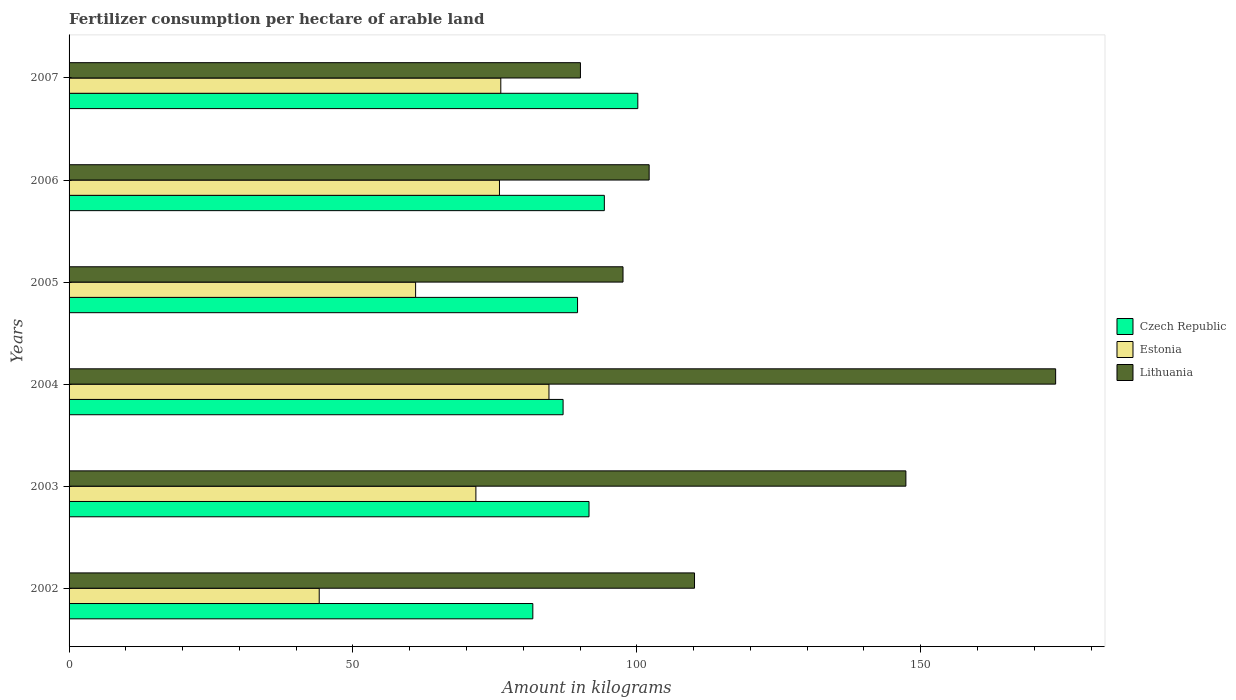How many different coloured bars are there?
Keep it short and to the point. 3. How many groups of bars are there?
Your answer should be very brief. 6. Are the number of bars per tick equal to the number of legend labels?
Your response must be concise. Yes. Are the number of bars on each tick of the Y-axis equal?
Provide a succinct answer. Yes. How many bars are there on the 4th tick from the top?
Provide a succinct answer. 3. How many bars are there on the 2nd tick from the bottom?
Offer a very short reply. 3. What is the label of the 6th group of bars from the top?
Your response must be concise. 2002. What is the amount of fertilizer consumption in Lithuania in 2002?
Provide a succinct answer. 110.15. Across all years, what is the maximum amount of fertilizer consumption in Czech Republic?
Offer a very short reply. 100.17. Across all years, what is the minimum amount of fertilizer consumption in Czech Republic?
Keep it short and to the point. 81.68. What is the total amount of fertilizer consumption in Estonia in the graph?
Keep it short and to the point. 413.1. What is the difference between the amount of fertilizer consumption in Estonia in 2002 and that in 2004?
Make the answer very short. -40.46. What is the difference between the amount of fertilizer consumption in Lithuania in 2004 and the amount of fertilizer consumption in Czech Republic in 2003?
Your answer should be very brief. 82.19. What is the average amount of fertilizer consumption in Estonia per year?
Your answer should be compact. 68.85. In the year 2002, what is the difference between the amount of fertilizer consumption in Czech Republic and amount of fertilizer consumption in Estonia?
Ensure brevity in your answer.  37.62. What is the ratio of the amount of fertilizer consumption in Estonia in 2003 to that in 2005?
Provide a short and direct response. 1.17. Is the amount of fertilizer consumption in Estonia in 2006 less than that in 2007?
Your answer should be very brief. Yes. What is the difference between the highest and the second highest amount of fertilizer consumption in Czech Republic?
Your response must be concise. 5.9. What is the difference between the highest and the lowest amount of fertilizer consumption in Estonia?
Give a very brief answer. 40.46. Is the sum of the amount of fertilizer consumption in Czech Republic in 2005 and 2006 greater than the maximum amount of fertilizer consumption in Lithuania across all years?
Keep it short and to the point. Yes. What does the 2nd bar from the top in 2004 represents?
Your answer should be very brief. Estonia. What does the 1st bar from the bottom in 2004 represents?
Provide a succinct answer. Czech Republic. Is it the case that in every year, the sum of the amount of fertilizer consumption in Czech Republic and amount of fertilizer consumption in Lithuania is greater than the amount of fertilizer consumption in Estonia?
Your answer should be compact. Yes. How many years are there in the graph?
Make the answer very short. 6. What is the difference between two consecutive major ticks on the X-axis?
Make the answer very short. 50. Does the graph contain any zero values?
Your answer should be very brief. No. Where does the legend appear in the graph?
Provide a succinct answer. Center right. How many legend labels are there?
Your answer should be very brief. 3. How are the legend labels stacked?
Give a very brief answer. Vertical. What is the title of the graph?
Give a very brief answer. Fertilizer consumption per hectare of arable land. What is the label or title of the X-axis?
Make the answer very short. Amount in kilograms. What is the label or title of the Y-axis?
Your answer should be very brief. Years. What is the Amount in kilograms of Czech Republic in 2002?
Offer a terse response. 81.68. What is the Amount in kilograms of Estonia in 2002?
Provide a succinct answer. 44.06. What is the Amount in kilograms of Lithuania in 2002?
Provide a short and direct response. 110.15. What is the Amount in kilograms in Czech Republic in 2003?
Ensure brevity in your answer.  91.57. What is the Amount in kilograms in Estonia in 2003?
Give a very brief answer. 71.65. What is the Amount in kilograms in Lithuania in 2003?
Ensure brevity in your answer.  147.38. What is the Amount in kilograms of Czech Republic in 2004?
Offer a terse response. 87.01. What is the Amount in kilograms of Estonia in 2004?
Your answer should be very brief. 84.52. What is the Amount in kilograms of Lithuania in 2004?
Make the answer very short. 173.76. What is the Amount in kilograms in Czech Republic in 2005?
Give a very brief answer. 89.56. What is the Amount in kilograms of Estonia in 2005?
Your answer should be compact. 61.03. What is the Amount in kilograms in Lithuania in 2005?
Keep it short and to the point. 97.56. What is the Amount in kilograms of Czech Republic in 2006?
Your answer should be very brief. 94.27. What is the Amount in kilograms of Estonia in 2006?
Your response must be concise. 75.8. What is the Amount in kilograms of Lithuania in 2006?
Provide a succinct answer. 102.17. What is the Amount in kilograms of Czech Republic in 2007?
Your answer should be compact. 100.17. What is the Amount in kilograms of Estonia in 2007?
Ensure brevity in your answer.  76.04. What is the Amount in kilograms in Lithuania in 2007?
Your answer should be very brief. 90.07. Across all years, what is the maximum Amount in kilograms of Czech Republic?
Offer a very short reply. 100.17. Across all years, what is the maximum Amount in kilograms of Estonia?
Give a very brief answer. 84.52. Across all years, what is the maximum Amount in kilograms in Lithuania?
Keep it short and to the point. 173.76. Across all years, what is the minimum Amount in kilograms of Czech Republic?
Offer a terse response. 81.68. Across all years, what is the minimum Amount in kilograms in Estonia?
Keep it short and to the point. 44.06. Across all years, what is the minimum Amount in kilograms of Lithuania?
Your answer should be very brief. 90.07. What is the total Amount in kilograms of Czech Republic in the graph?
Provide a succinct answer. 544.26. What is the total Amount in kilograms of Estonia in the graph?
Offer a very short reply. 413.1. What is the total Amount in kilograms of Lithuania in the graph?
Your answer should be compact. 721.1. What is the difference between the Amount in kilograms in Czech Republic in 2002 and that in 2003?
Offer a very short reply. -9.9. What is the difference between the Amount in kilograms in Estonia in 2002 and that in 2003?
Offer a terse response. -27.59. What is the difference between the Amount in kilograms in Lithuania in 2002 and that in 2003?
Your answer should be compact. -37.23. What is the difference between the Amount in kilograms of Czech Republic in 2002 and that in 2004?
Your response must be concise. -5.33. What is the difference between the Amount in kilograms in Estonia in 2002 and that in 2004?
Ensure brevity in your answer.  -40.46. What is the difference between the Amount in kilograms in Lithuania in 2002 and that in 2004?
Keep it short and to the point. -63.61. What is the difference between the Amount in kilograms in Czech Republic in 2002 and that in 2005?
Your answer should be very brief. -7.88. What is the difference between the Amount in kilograms of Estonia in 2002 and that in 2005?
Your answer should be very brief. -16.98. What is the difference between the Amount in kilograms of Lithuania in 2002 and that in 2005?
Your answer should be compact. 12.59. What is the difference between the Amount in kilograms of Czech Republic in 2002 and that in 2006?
Provide a succinct answer. -12.59. What is the difference between the Amount in kilograms in Estonia in 2002 and that in 2006?
Provide a succinct answer. -31.75. What is the difference between the Amount in kilograms of Lithuania in 2002 and that in 2006?
Your answer should be compact. 7.99. What is the difference between the Amount in kilograms of Czech Republic in 2002 and that in 2007?
Keep it short and to the point. -18.49. What is the difference between the Amount in kilograms in Estonia in 2002 and that in 2007?
Offer a terse response. -31.98. What is the difference between the Amount in kilograms of Lithuania in 2002 and that in 2007?
Keep it short and to the point. 20.09. What is the difference between the Amount in kilograms of Czech Republic in 2003 and that in 2004?
Your response must be concise. 4.57. What is the difference between the Amount in kilograms of Estonia in 2003 and that in 2004?
Offer a terse response. -12.87. What is the difference between the Amount in kilograms of Lithuania in 2003 and that in 2004?
Provide a succinct answer. -26.38. What is the difference between the Amount in kilograms of Czech Republic in 2003 and that in 2005?
Provide a short and direct response. 2.02. What is the difference between the Amount in kilograms in Estonia in 2003 and that in 2005?
Make the answer very short. 10.62. What is the difference between the Amount in kilograms of Lithuania in 2003 and that in 2005?
Provide a short and direct response. 49.82. What is the difference between the Amount in kilograms of Czech Republic in 2003 and that in 2006?
Your answer should be very brief. -2.7. What is the difference between the Amount in kilograms in Estonia in 2003 and that in 2006?
Provide a short and direct response. -4.15. What is the difference between the Amount in kilograms in Lithuania in 2003 and that in 2006?
Your answer should be very brief. 45.22. What is the difference between the Amount in kilograms of Czech Republic in 2003 and that in 2007?
Offer a terse response. -8.6. What is the difference between the Amount in kilograms of Estonia in 2003 and that in 2007?
Ensure brevity in your answer.  -4.39. What is the difference between the Amount in kilograms of Lithuania in 2003 and that in 2007?
Provide a short and direct response. 57.32. What is the difference between the Amount in kilograms in Czech Republic in 2004 and that in 2005?
Offer a very short reply. -2.55. What is the difference between the Amount in kilograms of Estonia in 2004 and that in 2005?
Your response must be concise. 23.49. What is the difference between the Amount in kilograms of Lithuania in 2004 and that in 2005?
Provide a succinct answer. 76.2. What is the difference between the Amount in kilograms of Czech Republic in 2004 and that in 2006?
Make the answer very short. -7.27. What is the difference between the Amount in kilograms of Estonia in 2004 and that in 2006?
Your response must be concise. 8.72. What is the difference between the Amount in kilograms in Lithuania in 2004 and that in 2006?
Your answer should be compact. 71.59. What is the difference between the Amount in kilograms in Czech Republic in 2004 and that in 2007?
Offer a very short reply. -13.16. What is the difference between the Amount in kilograms of Estonia in 2004 and that in 2007?
Give a very brief answer. 8.48. What is the difference between the Amount in kilograms of Lithuania in 2004 and that in 2007?
Offer a very short reply. 83.69. What is the difference between the Amount in kilograms in Czech Republic in 2005 and that in 2006?
Your answer should be very brief. -4.72. What is the difference between the Amount in kilograms of Estonia in 2005 and that in 2006?
Keep it short and to the point. -14.77. What is the difference between the Amount in kilograms of Lithuania in 2005 and that in 2006?
Your response must be concise. -4.6. What is the difference between the Amount in kilograms in Czech Republic in 2005 and that in 2007?
Provide a succinct answer. -10.61. What is the difference between the Amount in kilograms of Estonia in 2005 and that in 2007?
Give a very brief answer. -15. What is the difference between the Amount in kilograms of Lithuania in 2005 and that in 2007?
Your response must be concise. 7.5. What is the difference between the Amount in kilograms of Czech Republic in 2006 and that in 2007?
Your answer should be compact. -5.9. What is the difference between the Amount in kilograms in Estonia in 2006 and that in 2007?
Offer a very short reply. -0.23. What is the difference between the Amount in kilograms of Lithuania in 2006 and that in 2007?
Keep it short and to the point. 12.1. What is the difference between the Amount in kilograms in Czech Republic in 2002 and the Amount in kilograms in Estonia in 2003?
Provide a succinct answer. 10.03. What is the difference between the Amount in kilograms in Czech Republic in 2002 and the Amount in kilograms in Lithuania in 2003?
Provide a short and direct response. -65.71. What is the difference between the Amount in kilograms in Estonia in 2002 and the Amount in kilograms in Lithuania in 2003?
Your response must be concise. -103.33. What is the difference between the Amount in kilograms of Czech Republic in 2002 and the Amount in kilograms of Estonia in 2004?
Your response must be concise. -2.84. What is the difference between the Amount in kilograms in Czech Republic in 2002 and the Amount in kilograms in Lithuania in 2004?
Your answer should be compact. -92.08. What is the difference between the Amount in kilograms in Estonia in 2002 and the Amount in kilograms in Lithuania in 2004?
Make the answer very short. -129.7. What is the difference between the Amount in kilograms in Czech Republic in 2002 and the Amount in kilograms in Estonia in 2005?
Your response must be concise. 20.65. What is the difference between the Amount in kilograms in Czech Republic in 2002 and the Amount in kilograms in Lithuania in 2005?
Provide a succinct answer. -15.88. What is the difference between the Amount in kilograms of Estonia in 2002 and the Amount in kilograms of Lithuania in 2005?
Give a very brief answer. -53.51. What is the difference between the Amount in kilograms in Czech Republic in 2002 and the Amount in kilograms in Estonia in 2006?
Make the answer very short. 5.88. What is the difference between the Amount in kilograms in Czech Republic in 2002 and the Amount in kilograms in Lithuania in 2006?
Your answer should be very brief. -20.49. What is the difference between the Amount in kilograms in Estonia in 2002 and the Amount in kilograms in Lithuania in 2006?
Keep it short and to the point. -58.11. What is the difference between the Amount in kilograms of Czech Republic in 2002 and the Amount in kilograms of Estonia in 2007?
Your answer should be very brief. 5.64. What is the difference between the Amount in kilograms of Czech Republic in 2002 and the Amount in kilograms of Lithuania in 2007?
Your answer should be very brief. -8.39. What is the difference between the Amount in kilograms in Estonia in 2002 and the Amount in kilograms in Lithuania in 2007?
Provide a short and direct response. -46.01. What is the difference between the Amount in kilograms of Czech Republic in 2003 and the Amount in kilograms of Estonia in 2004?
Your answer should be compact. 7.05. What is the difference between the Amount in kilograms in Czech Republic in 2003 and the Amount in kilograms in Lithuania in 2004?
Provide a short and direct response. -82.19. What is the difference between the Amount in kilograms in Estonia in 2003 and the Amount in kilograms in Lithuania in 2004?
Provide a short and direct response. -102.11. What is the difference between the Amount in kilograms of Czech Republic in 2003 and the Amount in kilograms of Estonia in 2005?
Provide a short and direct response. 30.54. What is the difference between the Amount in kilograms of Czech Republic in 2003 and the Amount in kilograms of Lithuania in 2005?
Your answer should be compact. -5.99. What is the difference between the Amount in kilograms in Estonia in 2003 and the Amount in kilograms in Lithuania in 2005?
Make the answer very short. -25.91. What is the difference between the Amount in kilograms of Czech Republic in 2003 and the Amount in kilograms of Estonia in 2006?
Offer a very short reply. 15.77. What is the difference between the Amount in kilograms of Czech Republic in 2003 and the Amount in kilograms of Lithuania in 2006?
Give a very brief answer. -10.59. What is the difference between the Amount in kilograms of Estonia in 2003 and the Amount in kilograms of Lithuania in 2006?
Give a very brief answer. -30.52. What is the difference between the Amount in kilograms in Czech Republic in 2003 and the Amount in kilograms in Estonia in 2007?
Provide a short and direct response. 15.54. What is the difference between the Amount in kilograms of Czech Republic in 2003 and the Amount in kilograms of Lithuania in 2007?
Provide a succinct answer. 1.51. What is the difference between the Amount in kilograms in Estonia in 2003 and the Amount in kilograms in Lithuania in 2007?
Offer a terse response. -18.42. What is the difference between the Amount in kilograms in Czech Republic in 2004 and the Amount in kilograms in Estonia in 2005?
Your answer should be compact. 25.97. What is the difference between the Amount in kilograms in Czech Republic in 2004 and the Amount in kilograms in Lithuania in 2005?
Offer a very short reply. -10.56. What is the difference between the Amount in kilograms in Estonia in 2004 and the Amount in kilograms in Lithuania in 2005?
Offer a terse response. -13.04. What is the difference between the Amount in kilograms in Czech Republic in 2004 and the Amount in kilograms in Estonia in 2006?
Offer a very short reply. 11.21. What is the difference between the Amount in kilograms in Czech Republic in 2004 and the Amount in kilograms in Lithuania in 2006?
Provide a succinct answer. -15.16. What is the difference between the Amount in kilograms in Estonia in 2004 and the Amount in kilograms in Lithuania in 2006?
Make the answer very short. -17.65. What is the difference between the Amount in kilograms in Czech Republic in 2004 and the Amount in kilograms in Estonia in 2007?
Make the answer very short. 10.97. What is the difference between the Amount in kilograms in Czech Republic in 2004 and the Amount in kilograms in Lithuania in 2007?
Ensure brevity in your answer.  -3.06. What is the difference between the Amount in kilograms of Estonia in 2004 and the Amount in kilograms of Lithuania in 2007?
Keep it short and to the point. -5.54. What is the difference between the Amount in kilograms of Czech Republic in 2005 and the Amount in kilograms of Estonia in 2006?
Provide a succinct answer. 13.75. What is the difference between the Amount in kilograms of Czech Republic in 2005 and the Amount in kilograms of Lithuania in 2006?
Keep it short and to the point. -12.61. What is the difference between the Amount in kilograms of Estonia in 2005 and the Amount in kilograms of Lithuania in 2006?
Your answer should be very brief. -41.13. What is the difference between the Amount in kilograms of Czech Republic in 2005 and the Amount in kilograms of Estonia in 2007?
Offer a very short reply. 13.52. What is the difference between the Amount in kilograms of Czech Republic in 2005 and the Amount in kilograms of Lithuania in 2007?
Your response must be concise. -0.51. What is the difference between the Amount in kilograms of Estonia in 2005 and the Amount in kilograms of Lithuania in 2007?
Keep it short and to the point. -29.03. What is the difference between the Amount in kilograms in Czech Republic in 2006 and the Amount in kilograms in Estonia in 2007?
Provide a short and direct response. 18.24. What is the difference between the Amount in kilograms of Czech Republic in 2006 and the Amount in kilograms of Lithuania in 2007?
Your response must be concise. 4.21. What is the difference between the Amount in kilograms in Estonia in 2006 and the Amount in kilograms in Lithuania in 2007?
Provide a short and direct response. -14.26. What is the average Amount in kilograms of Czech Republic per year?
Provide a succinct answer. 90.71. What is the average Amount in kilograms of Estonia per year?
Give a very brief answer. 68.85. What is the average Amount in kilograms in Lithuania per year?
Offer a terse response. 120.18. In the year 2002, what is the difference between the Amount in kilograms in Czech Republic and Amount in kilograms in Estonia?
Offer a terse response. 37.62. In the year 2002, what is the difference between the Amount in kilograms in Czech Republic and Amount in kilograms in Lithuania?
Provide a succinct answer. -28.48. In the year 2002, what is the difference between the Amount in kilograms in Estonia and Amount in kilograms in Lithuania?
Make the answer very short. -66.1. In the year 2003, what is the difference between the Amount in kilograms of Czech Republic and Amount in kilograms of Estonia?
Provide a succinct answer. 19.92. In the year 2003, what is the difference between the Amount in kilograms in Czech Republic and Amount in kilograms in Lithuania?
Your response must be concise. -55.81. In the year 2003, what is the difference between the Amount in kilograms in Estonia and Amount in kilograms in Lithuania?
Provide a short and direct response. -75.73. In the year 2004, what is the difference between the Amount in kilograms in Czech Republic and Amount in kilograms in Estonia?
Offer a very short reply. 2.49. In the year 2004, what is the difference between the Amount in kilograms in Czech Republic and Amount in kilograms in Lithuania?
Keep it short and to the point. -86.75. In the year 2004, what is the difference between the Amount in kilograms of Estonia and Amount in kilograms of Lithuania?
Offer a very short reply. -89.24. In the year 2005, what is the difference between the Amount in kilograms in Czech Republic and Amount in kilograms in Estonia?
Keep it short and to the point. 28.52. In the year 2005, what is the difference between the Amount in kilograms in Czech Republic and Amount in kilograms in Lithuania?
Provide a succinct answer. -8.01. In the year 2005, what is the difference between the Amount in kilograms of Estonia and Amount in kilograms of Lithuania?
Your answer should be compact. -36.53. In the year 2006, what is the difference between the Amount in kilograms in Czech Republic and Amount in kilograms in Estonia?
Provide a succinct answer. 18.47. In the year 2006, what is the difference between the Amount in kilograms in Czech Republic and Amount in kilograms in Lithuania?
Your answer should be compact. -7.89. In the year 2006, what is the difference between the Amount in kilograms of Estonia and Amount in kilograms of Lithuania?
Offer a very short reply. -26.36. In the year 2007, what is the difference between the Amount in kilograms in Czech Republic and Amount in kilograms in Estonia?
Offer a terse response. 24.13. In the year 2007, what is the difference between the Amount in kilograms in Czech Republic and Amount in kilograms in Lithuania?
Offer a very short reply. 10.1. In the year 2007, what is the difference between the Amount in kilograms of Estonia and Amount in kilograms of Lithuania?
Your answer should be very brief. -14.03. What is the ratio of the Amount in kilograms in Czech Republic in 2002 to that in 2003?
Make the answer very short. 0.89. What is the ratio of the Amount in kilograms in Estonia in 2002 to that in 2003?
Keep it short and to the point. 0.61. What is the ratio of the Amount in kilograms in Lithuania in 2002 to that in 2003?
Provide a succinct answer. 0.75. What is the ratio of the Amount in kilograms of Czech Republic in 2002 to that in 2004?
Ensure brevity in your answer.  0.94. What is the ratio of the Amount in kilograms of Estonia in 2002 to that in 2004?
Provide a short and direct response. 0.52. What is the ratio of the Amount in kilograms of Lithuania in 2002 to that in 2004?
Provide a succinct answer. 0.63. What is the ratio of the Amount in kilograms in Czech Republic in 2002 to that in 2005?
Make the answer very short. 0.91. What is the ratio of the Amount in kilograms of Estonia in 2002 to that in 2005?
Provide a succinct answer. 0.72. What is the ratio of the Amount in kilograms of Lithuania in 2002 to that in 2005?
Your answer should be very brief. 1.13. What is the ratio of the Amount in kilograms in Czech Republic in 2002 to that in 2006?
Offer a very short reply. 0.87. What is the ratio of the Amount in kilograms of Estonia in 2002 to that in 2006?
Give a very brief answer. 0.58. What is the ratio of the Amount in kilograms of Lithuania in 2002 to that in 2006?
Give a very brief answer. 1.08. What is the ratio of the Amount in kilograms in Czech Republic in 2002 to that in 2007?
Your response must be concise. 0.82. What is the ratio of the Amount in kilograms of Estonia in 2002 to that in 2007?
Ensure brevity in your answer.  0.58. What is the ratio of the Amount in kilograms of Lithuania in 2002 to that in 2007?
Ensure brevity in your answer.  1.22. What is the ratio of the Amount in kilograms of Czech Republic in 2003 to that in 2004?
Provide a short and direct response. 1.05. What is the ratio of the Amount in kilograms in Estonia in 2003 to that in 2004?
Provide a short and direct response. 0.85. What is the ratio of the Amount in kilograms of Lithuania in 2003 to that in 2004?
Your response must be concise. 0.85. What is the ratio of the Amount in kilograms of Czech Republic in 2003 to that in 2005?
Give a very brief answer. 1.02. What is the ratio of the Amount in kilograms in Estonia in 2003 to that in 2005?
Provide a succinct answer. 1.17. What is the ratio of the Amount in kilograms of Lithuania in 2003 to that in 2005?
Keep it short and to the point. 1.51. What is the ratio of the Amount in kilograms in Czech Republic in 2003 to that in 2006?
Provide a succinct answer. 0.97. What is the ratio of the Amount in kilograms of Estonia in 2003 to that in 2006?
Offer a terse response. 0.95. What is the ratio of the Amount in kilograms in Lithuania in 2003 to that in 2006?
Your answer should be compact. 1.44. What is the ratio of the Amount in kilograms of Czech Republic in 2003 to that in 2007?
Keep it short and to the point. 0.91. What is the ratio of the Amount in kilograms of Estonia in 2003 to that in 2007?
Your answer should be very brief. 0.94. What is the ratio of the Amount in kilograms of Lithuania in 2003 to that in 2007?
Your response must be concise. 1.64. What is the ratio of the Amount in kilograms of Czech Republic in 2004 to that in 2005?
Make the answer very short. 0.97. What is the ratio of the Amount in kilograms in Estonia in 2004 to that in 2005?
Provide a succinct answer. 1.38. What is the ratio of the Amount in kilograms in Lithuania in 2004 to that in 2005?
Your answer should be compact. 1.78. What is the ratio of the Amount in kilograms of Czech Republic in 2004 to that in 2006?
Give a very brief answer. 0.92. What is the ratio of the Amount in kilograms of Estonia in 2004 to that in 2006?
Offer a very short reply. 1.11. What is the ratio of the Amount in kilograms in Lithuania in 2004 to that in 2006?
Your answer should be very brief. 1.7. What is the ratio of the Amount in kilograms of Czech Republic in 2004 to that in 2007?
Ensure brevity in your answer.  0.87. What is the ratio of the Amount in kilograms in Estonia in 2004 to that in 2007?
Your answer should be very brief. 1.11. What is the ratio of the Amount in kilograms in Lithuania in 2004 to that in 2007?
Keep it short and to the point. 1.93. What is the ratio of the Amount in kilograms of Czech Republic in 2005 to that in 2006?
Your answer should be very brief. 0.95. What is the ratio of the Amount in kilograms of Estonia in 2005 to that in 2006?
Offer a very short reply. 0.81. What is the ratio of the Amount in kilograms of Lithuania in 2005 to that in 2006?
Ensure brevity in your answer.  0.95. What is the ratio of the Amount in kilograms in Czech Republic in 2005 to that in 2007?
Your answer should be compact. 0.89. What is the ratio of the Amount in kilograms of Estonia in 2005 to that in 2007?
Keep it short and to the point. 0.8. What is the ratio of the Amount in kilograms of Czech Republic in 2006 to that in 2007?
Make the answer very short. 0.94. What is the ratio of the Amount in kilograms in Lithuania in 2006 to that in 2007?
Provide a succinct answer. 1.13. What is the difference between the highest and the second highest Amount in kilograms of Czech Republic?
Your response must be concise. 5.9. What is the difference between the highest and the second highest Amount in kilograms in Estonia?
Offer a very short reply. 8.48. What is the difference between the highest and the second highest Amount in kilograms in Lithuania?
Make the answer very short. 26.38. What is the difference between the highest and the lowest Amount in kilograms of Czech Republic?
Give a very brief answer. 18.49. What is the difference between the highest and the lowest Amount in kilograms of Estonia?
Your answer should be very brief. 40.46. What is the difference between the highest and the lowest Amount in kilograms in Lithuania?
Provide a succinct answer. 83.69. 